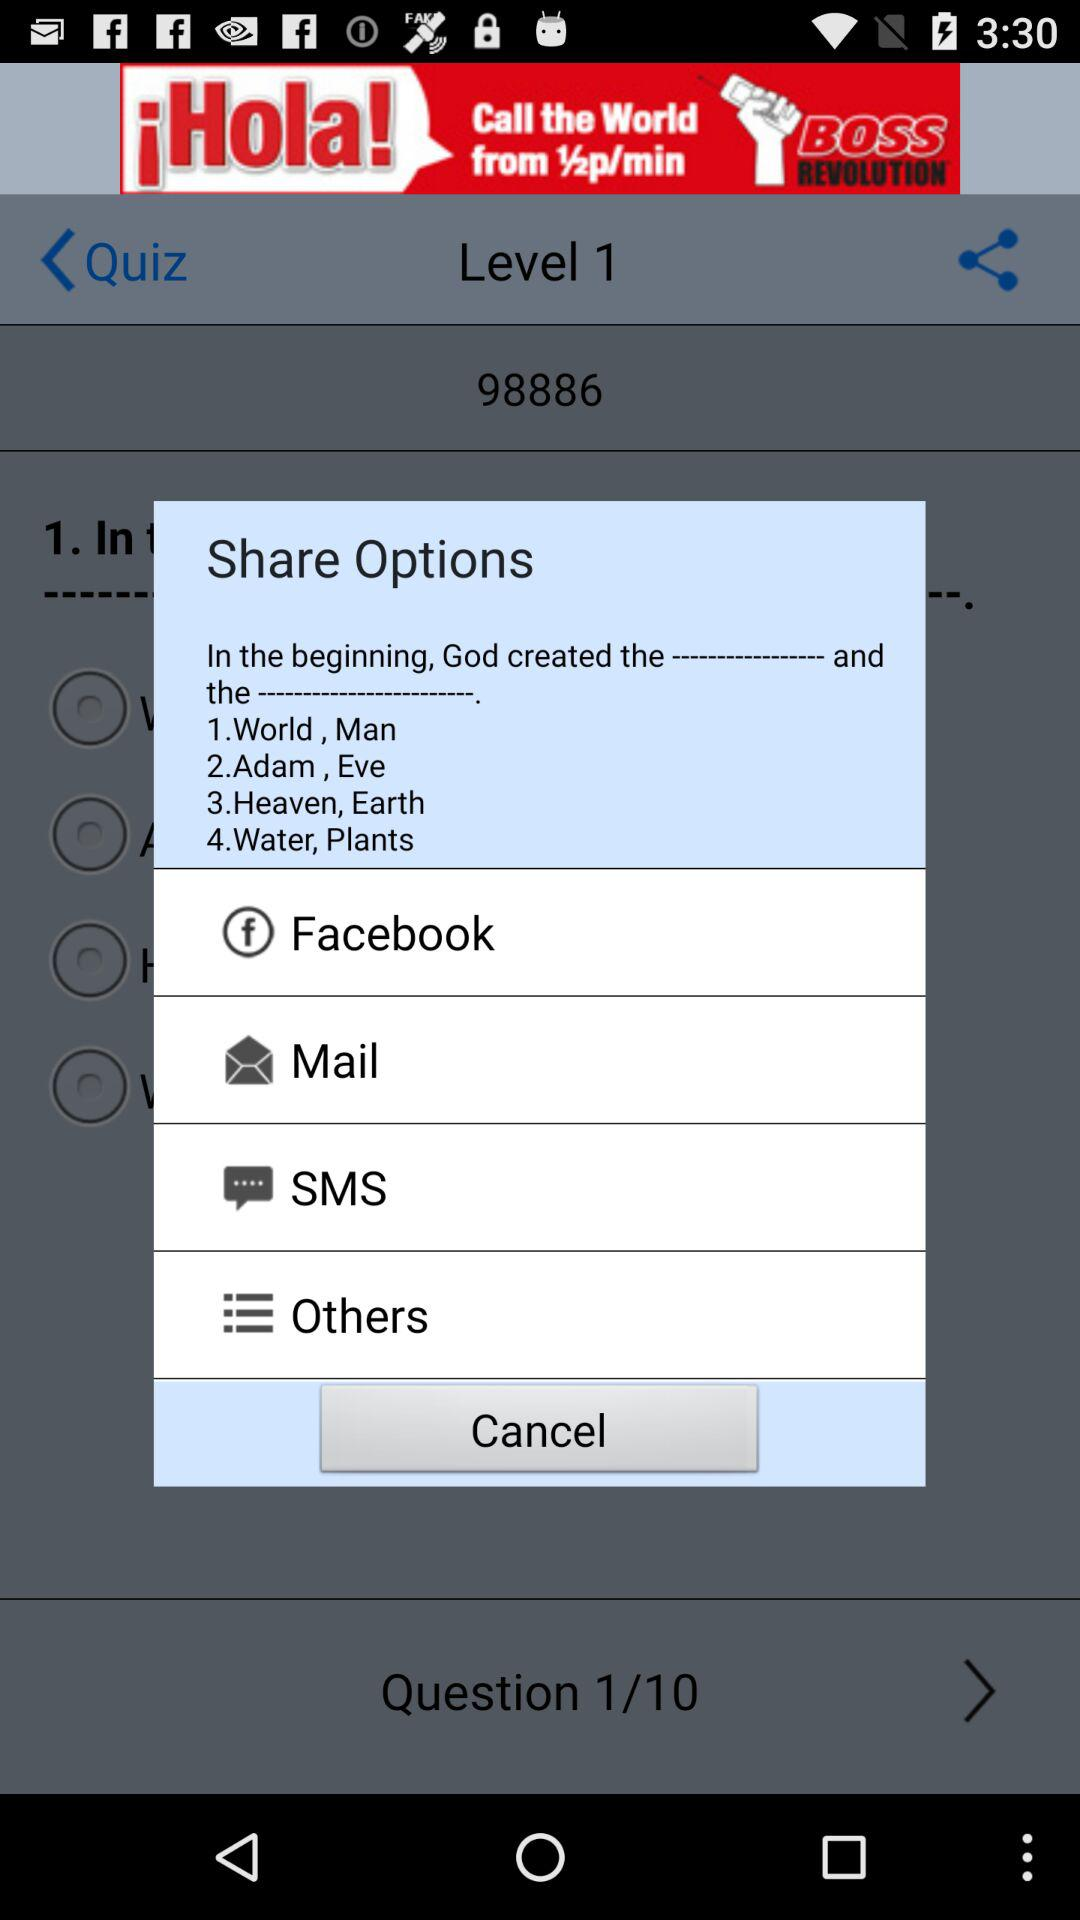Which option is selected?
When the provided information is insufficient, respond with <no answer>. <no answer> 